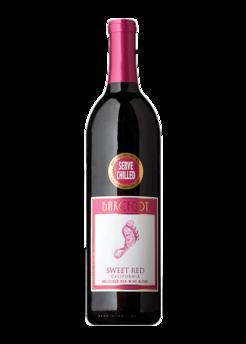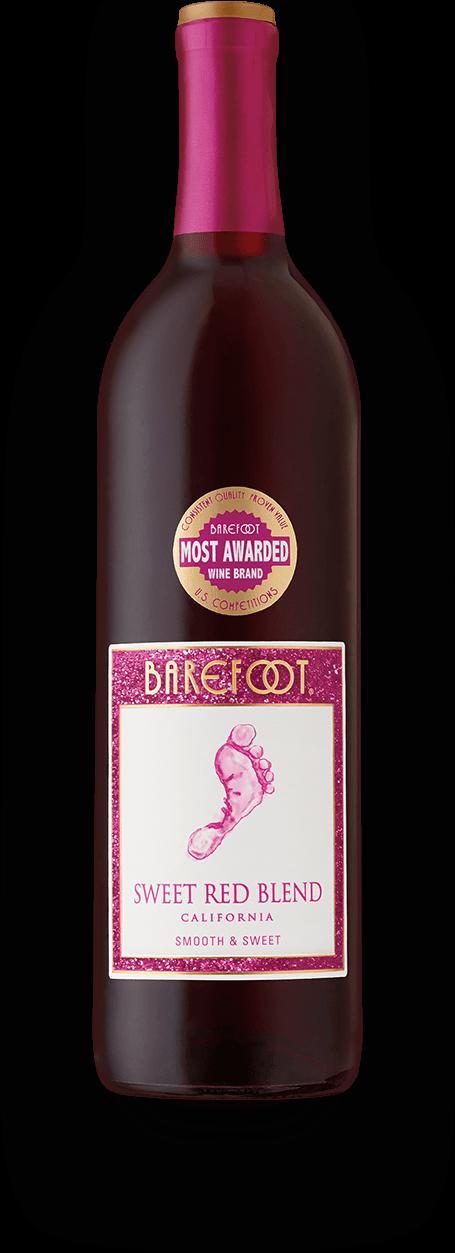The first image is the image on the left, the second image is the image on the right. For the images shown, is this caption "A total of two wine bottles are depicted." true? Answer yes or no. Yes. 